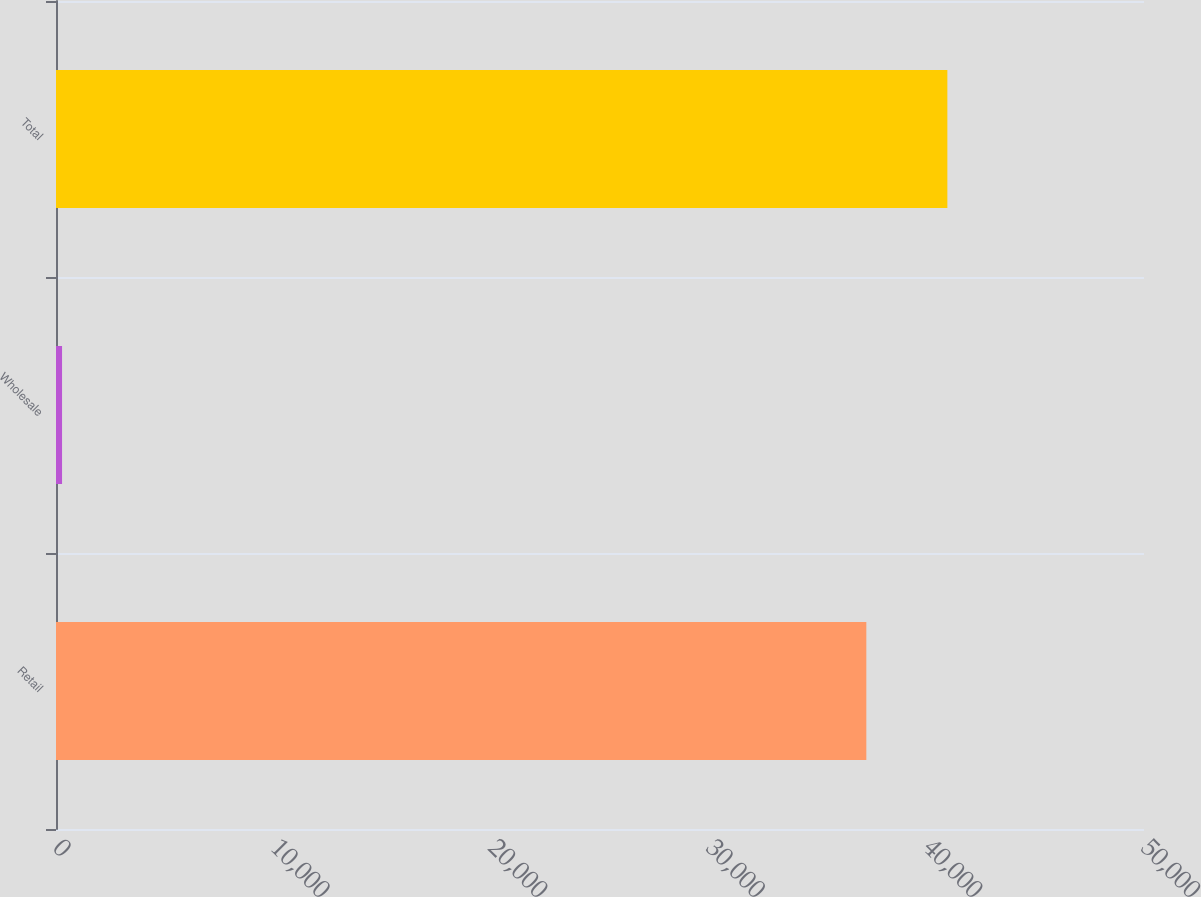<chart> <loc_0><loc_0><loc_500><loc_500><bar_chart><fcel>Retail<fcel>Wholesale<fcel>Total<nl><fcel>37239<fcel>278<fcel>40962.9<nl></chart> 